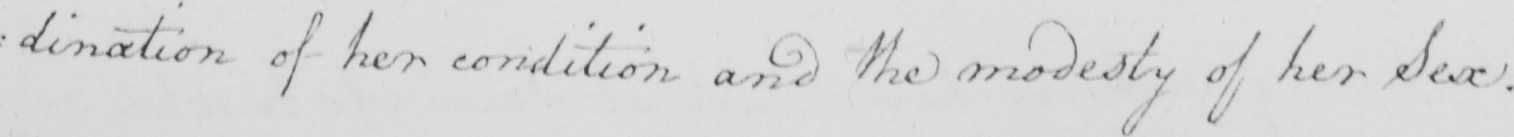Can you read and transcribe this handwriting? : dination of her condition and the modesty of her Sex . 